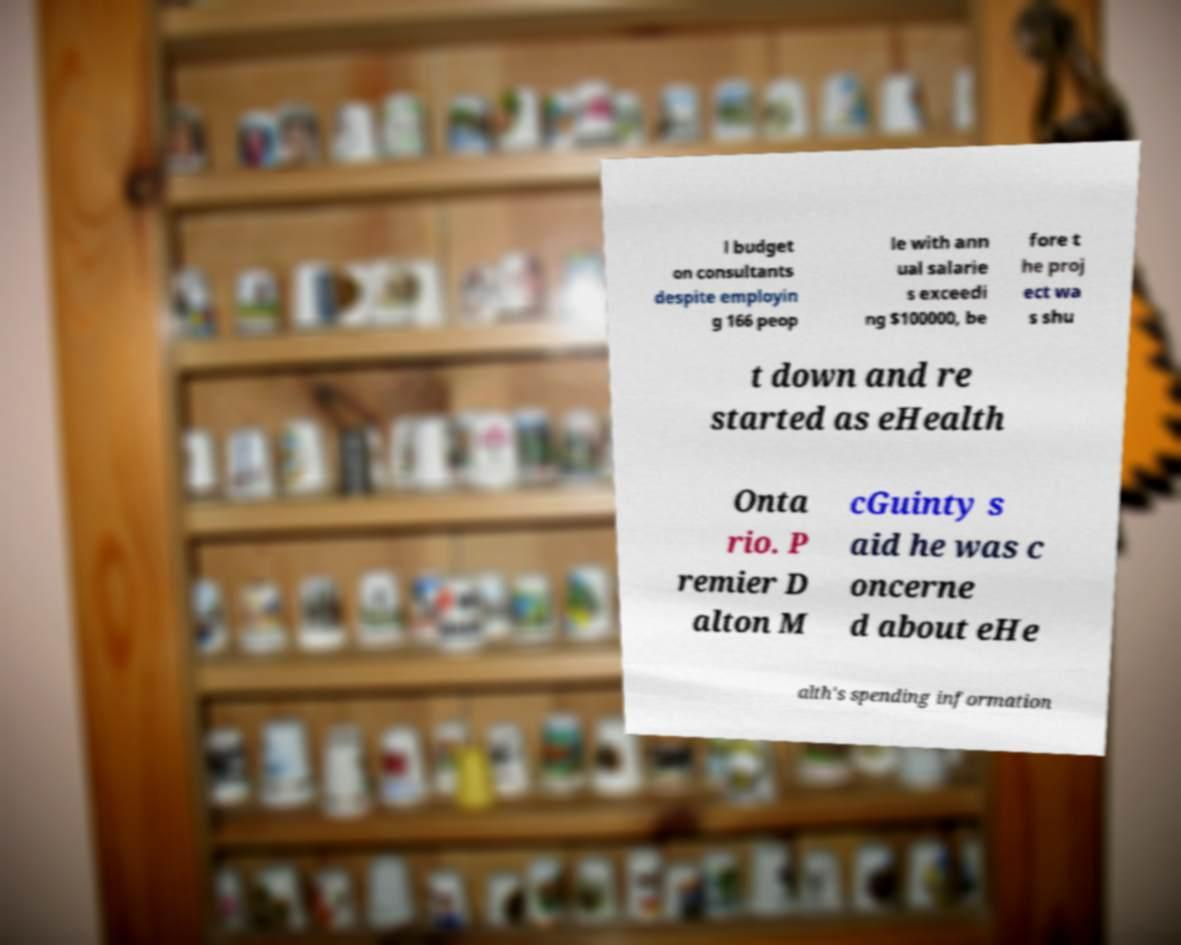Could you assist in decoding the text presented in this image and type it out clearly? l budget on consultants despite employin g 166 peop le with ann ual salarie s exceedi ng $100000, be fore t he proj ect wa s shu t down and re started as eHealth Onta rio. P remier D alton M cGuinty s aid he was c oncerne d about eHe alth's spending information 